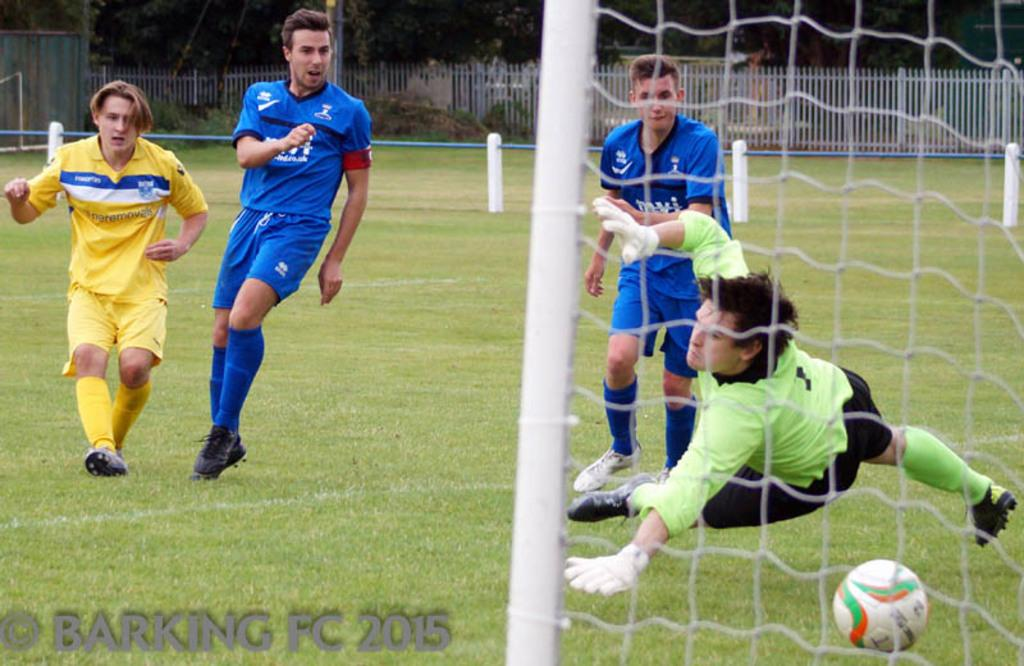What activity are the persons in the image engaged in? The persons in the image are playing football. Where is the football game taking place? The football game is taking place on a grassland. What can be seen in the background of the image? There is a fence in the background of the image, and trees are visible behind the fence. What type of vest is the horse wearing in the image? There is no horse present in the image, so it cannot be wearing a vest. 